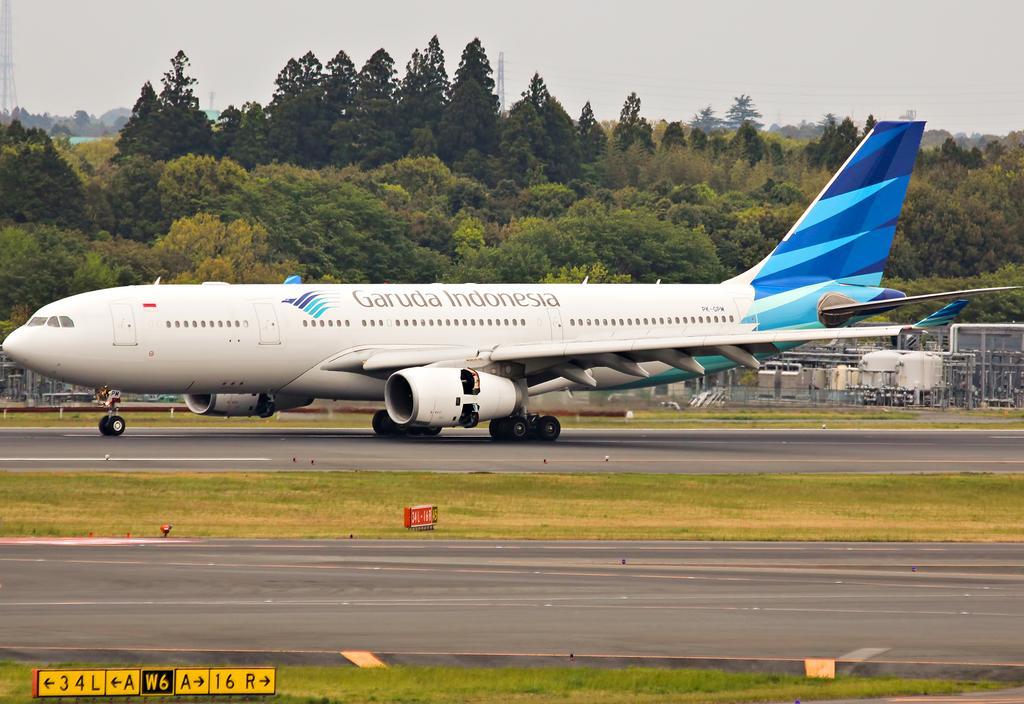Can you describe this image briefly? There is grassland and small number boards at the bottom side of the image, there is an aircraft, it seems like substation in the center. There are trees, pole and sky in the background area. 